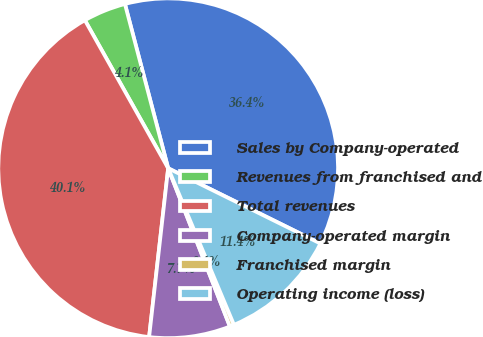Convert chart to OTSL. <chart><loc_0><loc_0><loc_500><loc_500><pie_chart><fcel>Sales by Company-operated<fcel>Revenues from franchised and<fcel>Total revenues<fcel>Company-operated margin<fcel>Franchised margin<fcel>Operating income (loss)<nl><fcel>36.4%<fcel>4.06%<fcel>40.05%<fcel>7.71%<fcel>0.41%<fcel>11.36%<nl></chart> 